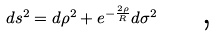Convert formula to latex. <formula><loc_0><loc_0><loc_500><loc_500>d s ^ { 2 } = d \rho ^ { 2 } + e ^ { - \frac { 2 \rho } { R } } d \sigma ^ { 2 } \text { \quad ,}</formula> 